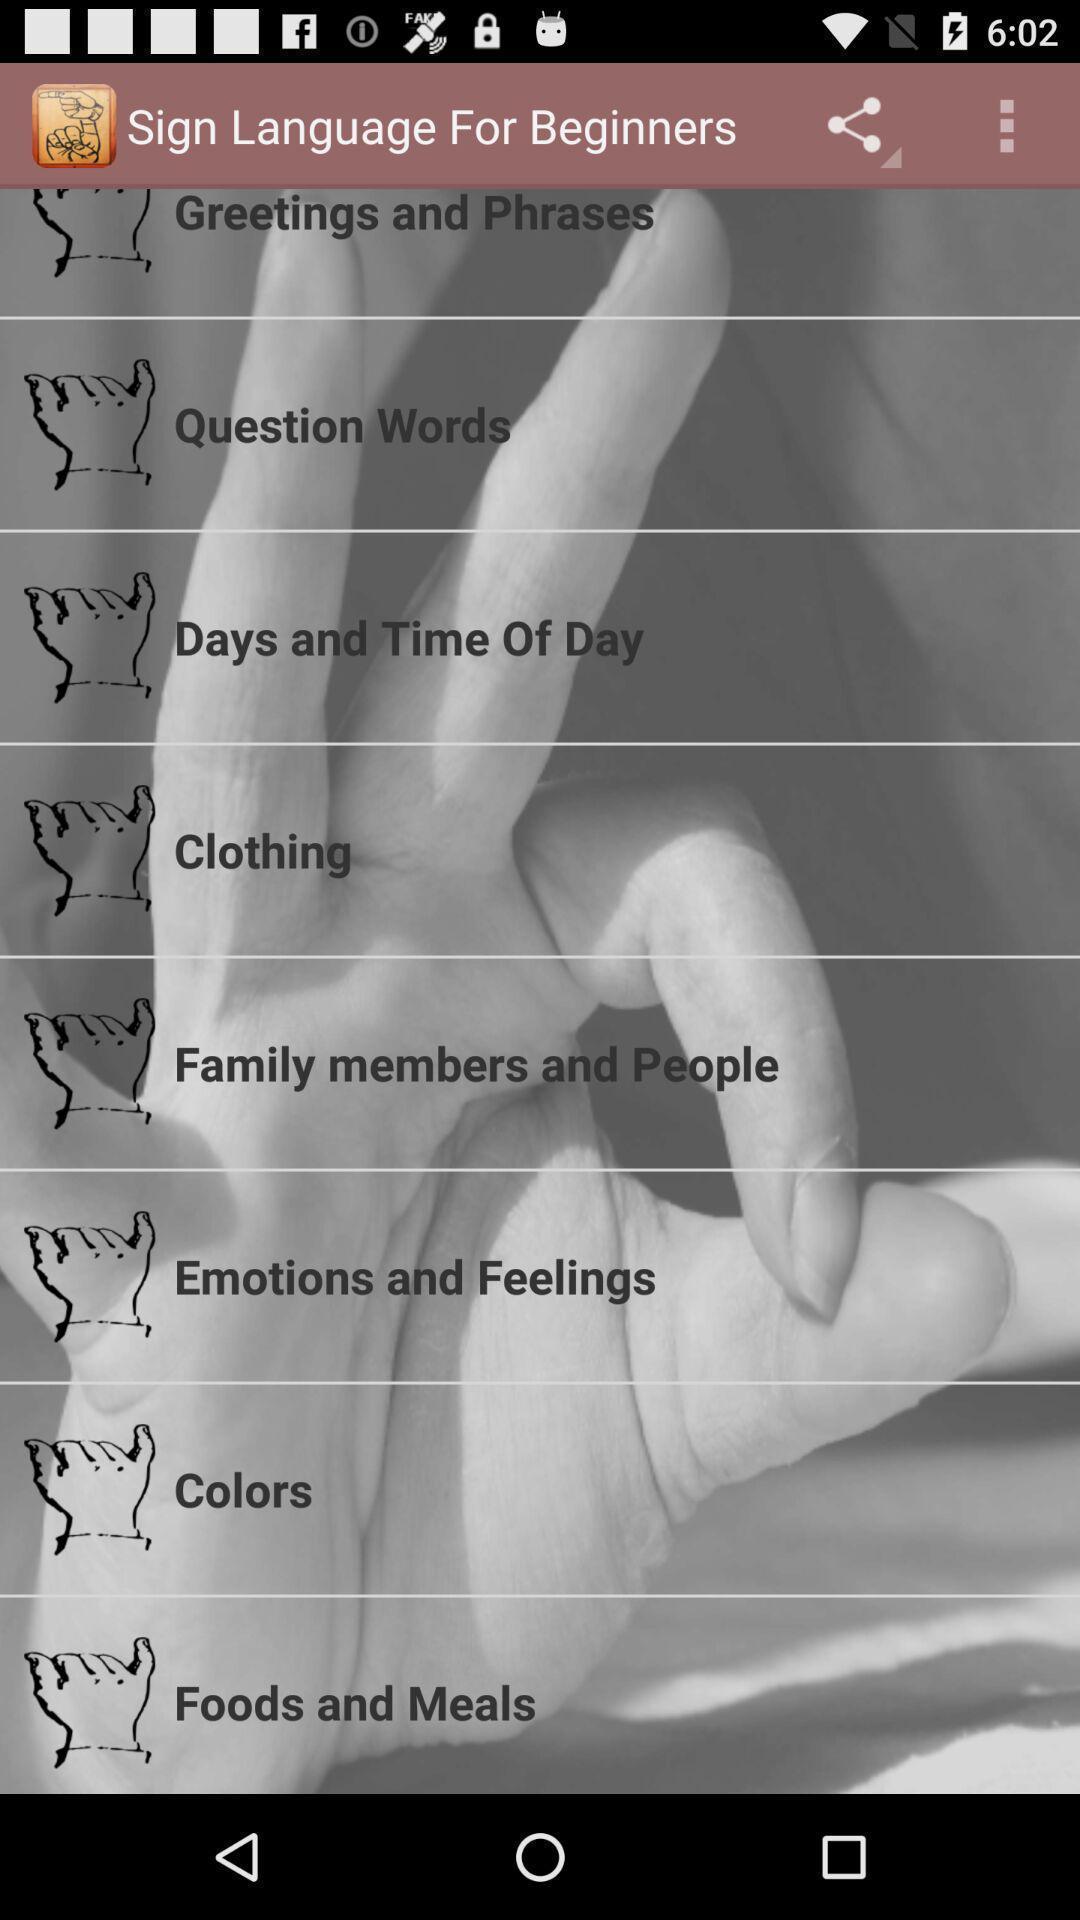Tell me about the visual elements in this screen capture. Page displaying list of options in app. 